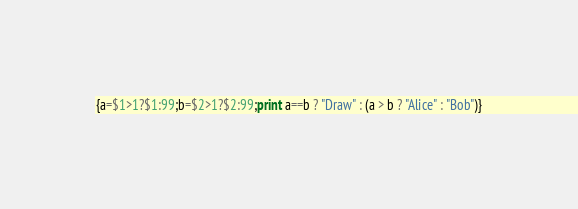<code> <loc_0><loc_0><loc_500><loc_500><_Awk_>{a=$1>1?$1:99;b=$2>1?$2:99;print a==b ? "Draw" : (a > b ? "Alice" : "Bob")}
</code> 